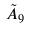Convert formula to latex. <formula><loc_0><loc_0><loc_500><loc_500>\tilde { A } _ { 9 }</formula> 